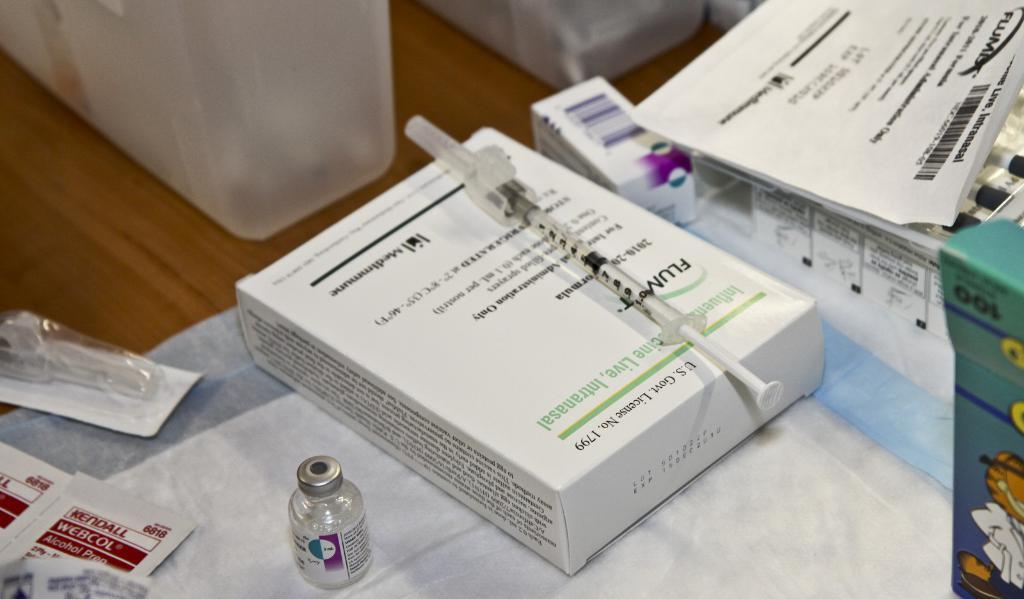<image>
Present a compact description of the photo's key features. A box with U.S. Govt. License No. 1799 printed on it with a syringe on top of it. 